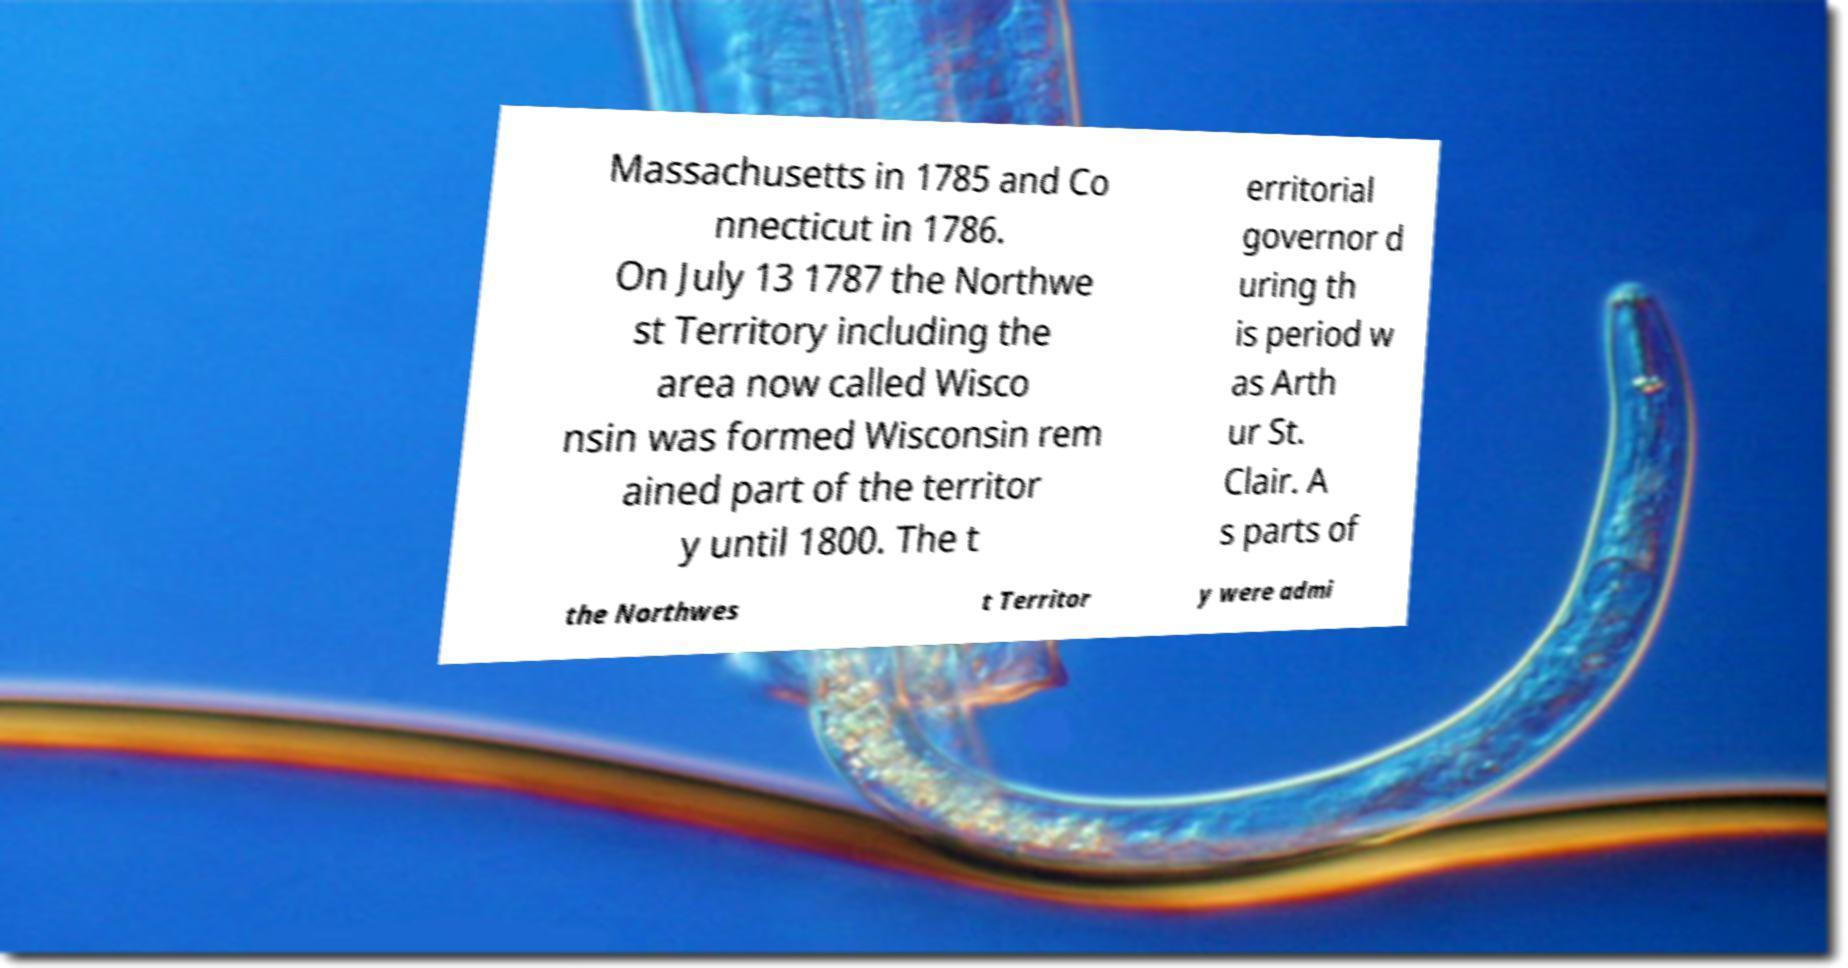Could you extract and type out the text from this image? Massachusetts in 1785 and Co nnecticut in 1786. On July 13 1787 the Northwe st Territory including the area now called Wisco nsin was formed Wisconsin rem ained part of the territor y until 1800. The t erritorial governor d uring th is period w as Arth ur St. Clair. A s parts of the Northwes t Territor y were admi 